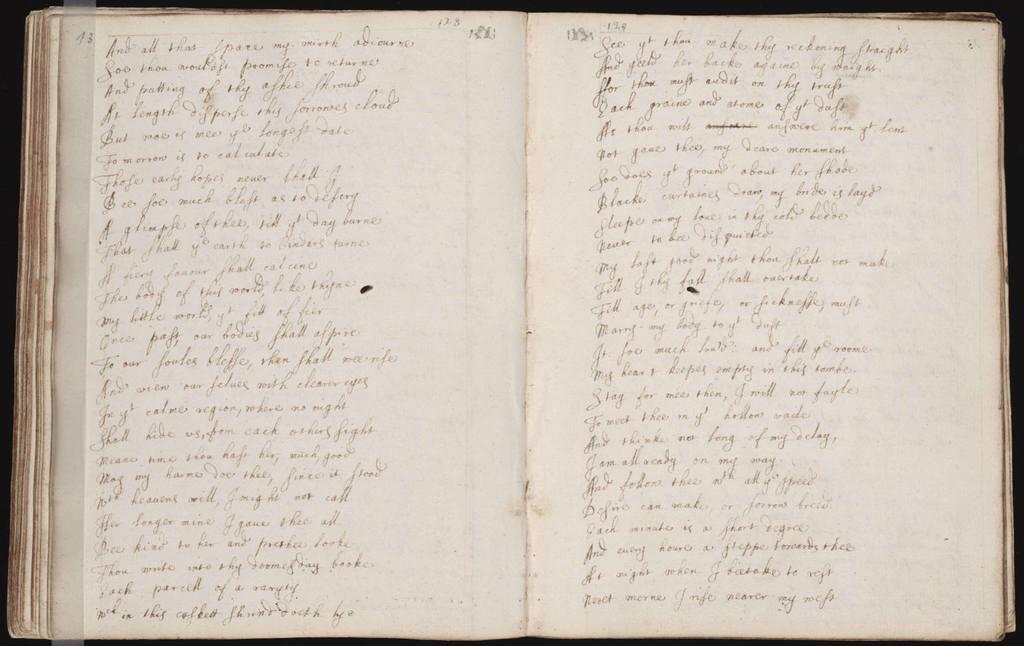What's the first word on the left page?
Provide a short and direct response. And. What is the number on the top left corner?
Give a very brief answer. 13. 